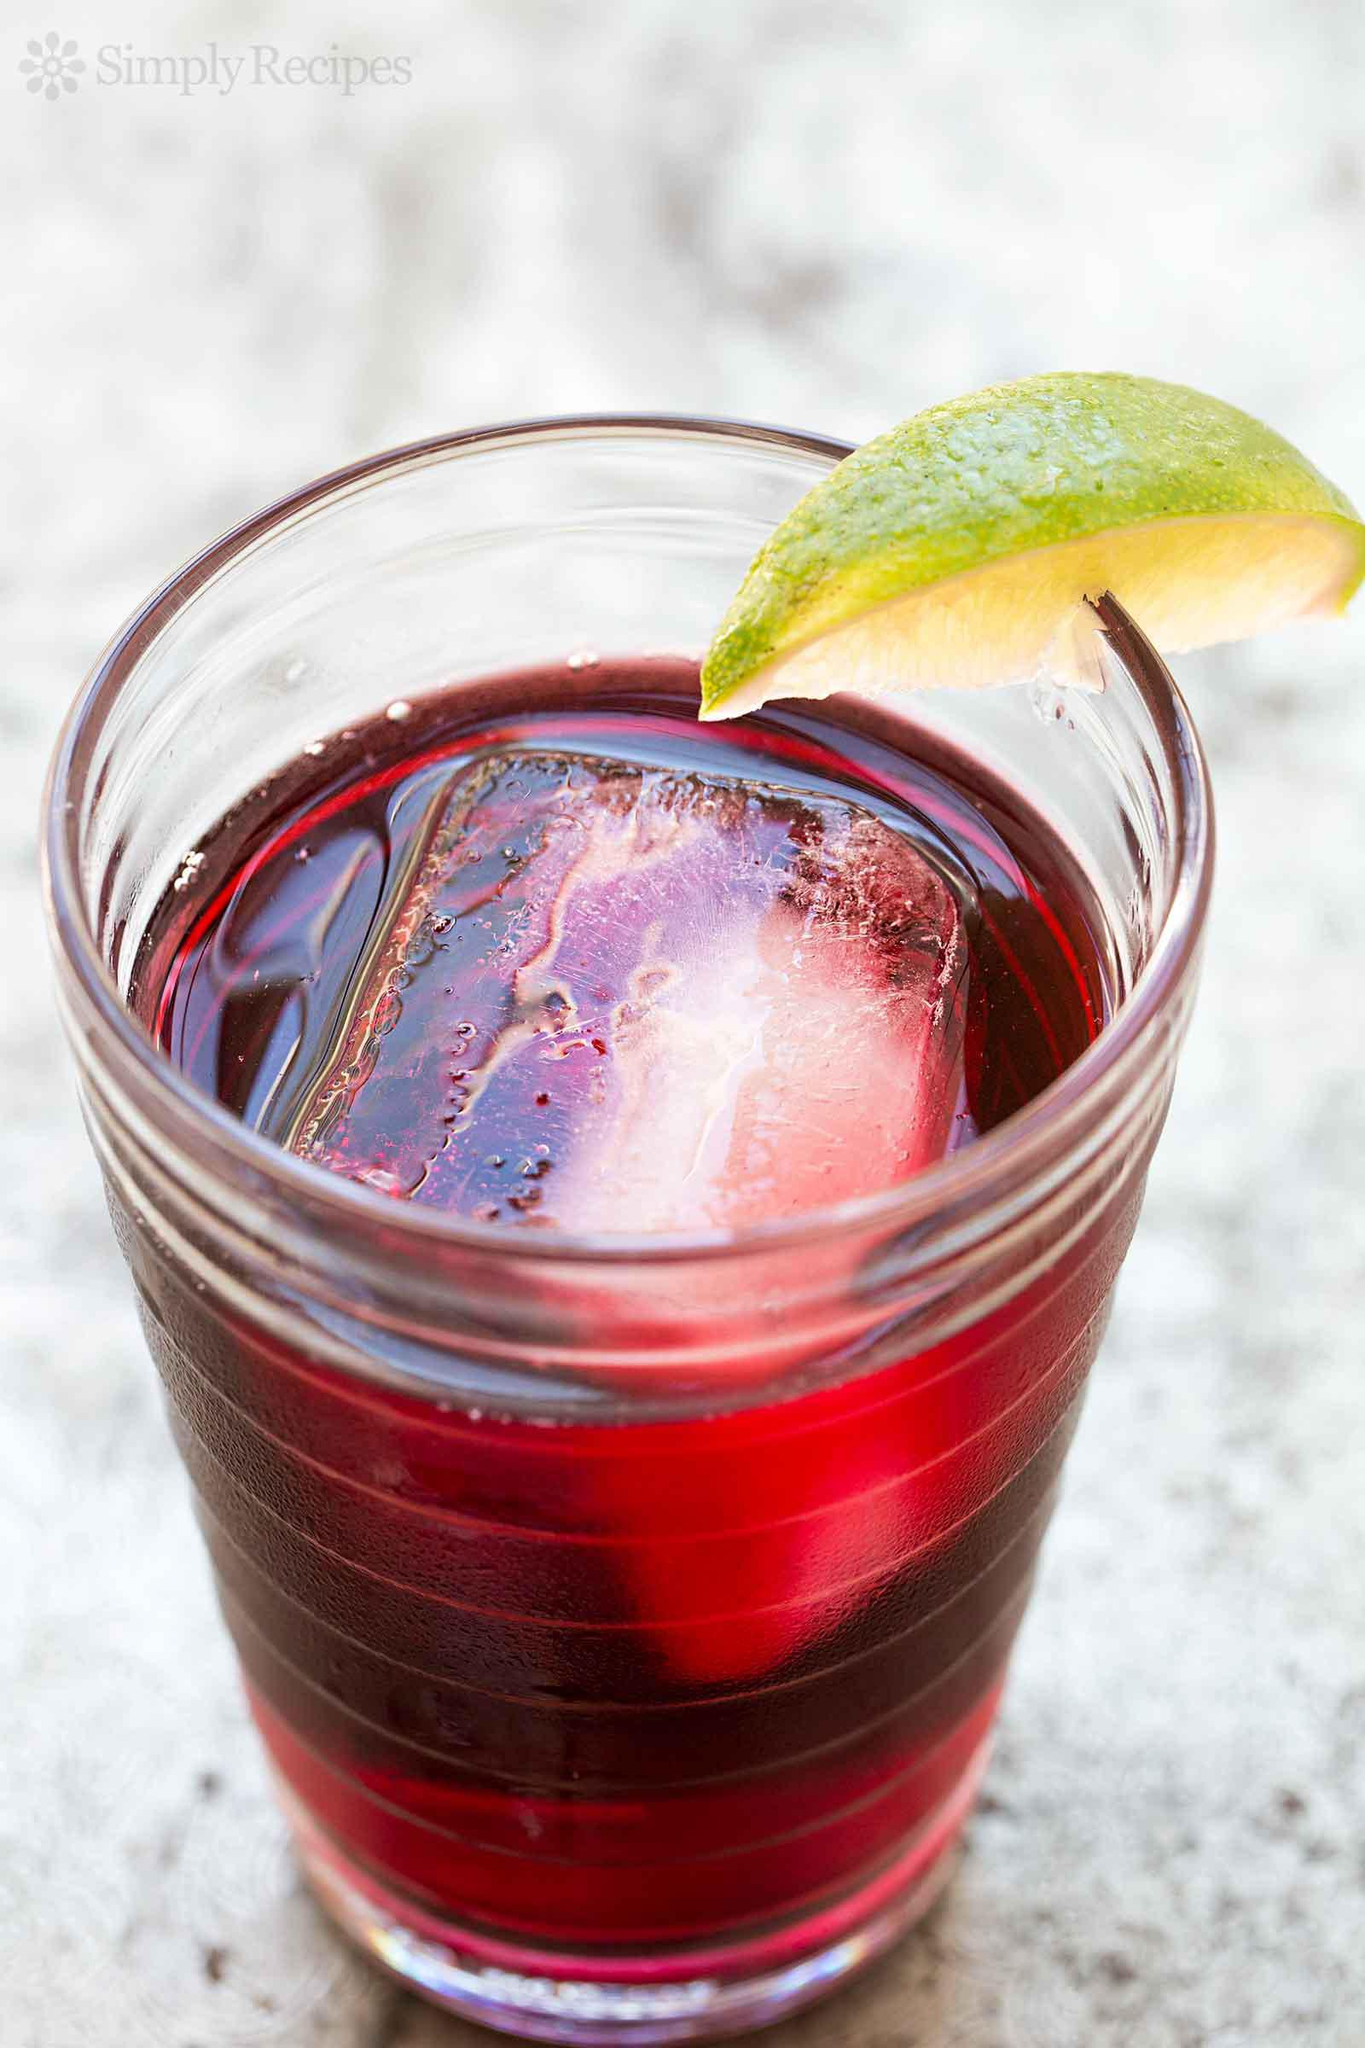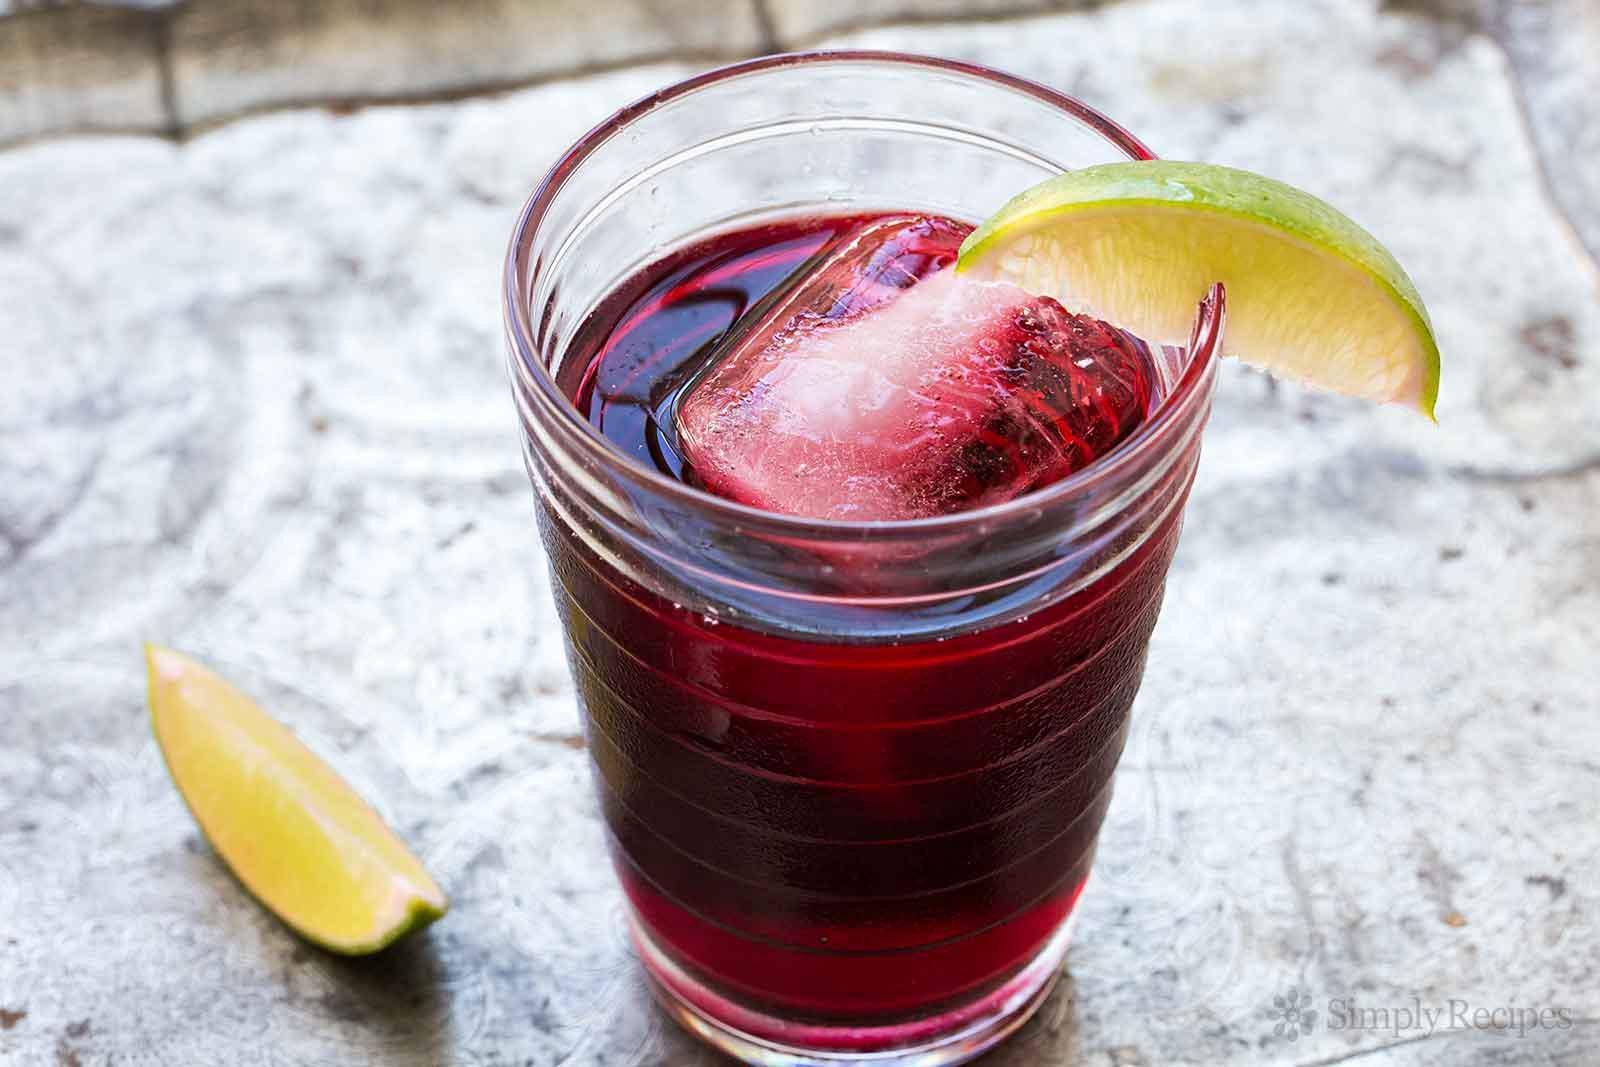The first image is the image on the left, the second image is the image on the right. Assess this claim about the two images: "At least one image shows a beverage with a lime wedge as its garnish.". Correct or not? Answer yes or no. Yes. The first image is the image on the left, the second image is the image on the right. Given the left and right images, does the statement "Lime is used as a garnish in at least one image." hold true? Answer yes or no. Yes. 